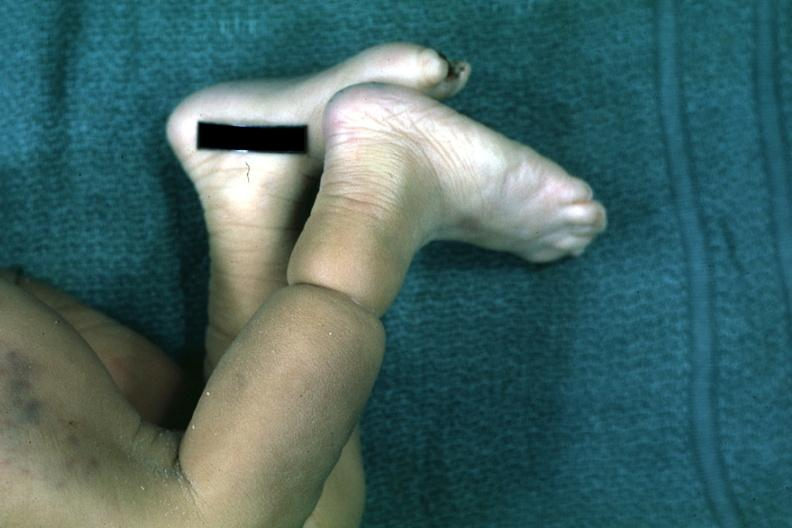what is present?
Answer the question using a single word or phrase. Band constriction in skin above ankle of infant 